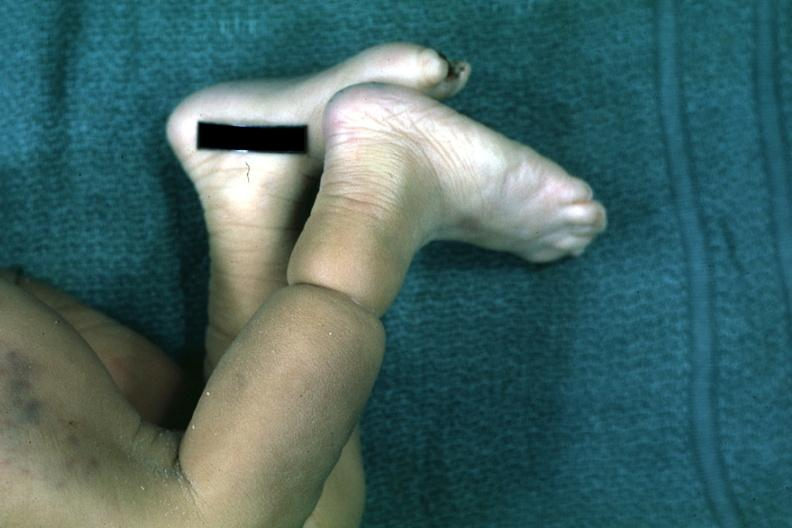what is present?
Answer the question using a single word or phrase. Band constriction in skin above ankle of infant 